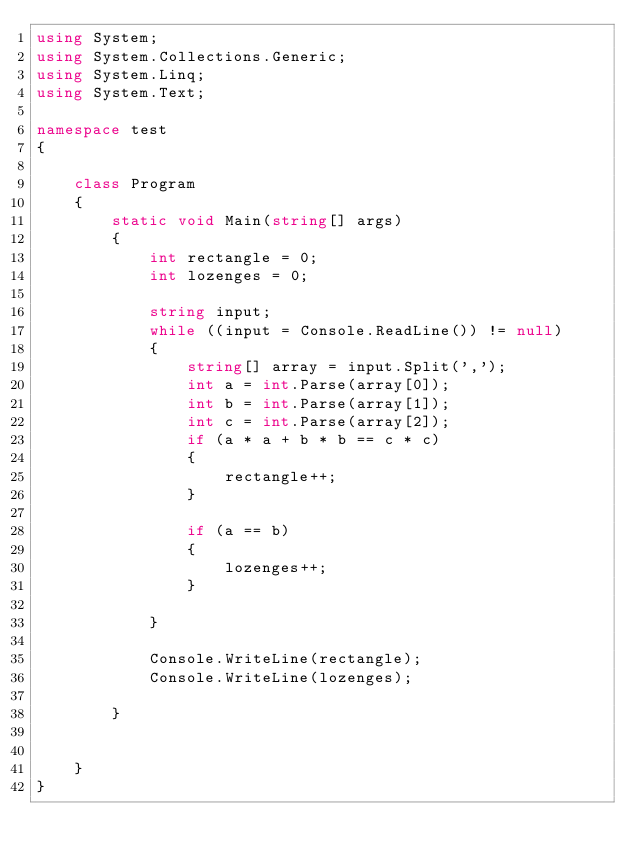Convert code to text. <code><loc_0><loc_0><loc_500><loc_500><_C#_>using System;
using System.Collections.Generic;
using System.Linq;
using System.Text;

namespace test
{

    class Program
    {
        static void Main(string[] args)
        {
            int rectangle = 0;
            int lozenges = 0;

            string input;
            while ((input = Console.ReadLine()) != null)
            {
                string[] array = input.Split(',');
                int a = int.Parse(array[0]);
                int b = int.Parse(array[1]);
                int c = int.Parse(array[2]);
                if (a * a + b * b == c * c)
                {
                    rectangle++;
                }

                if (a == b)
                {
                    lozenges++;
                }
                
            }

            Console.WriteLine(rectangle);
            Console.WriteLine(lozenges);

        }

        
    }
}</code> 